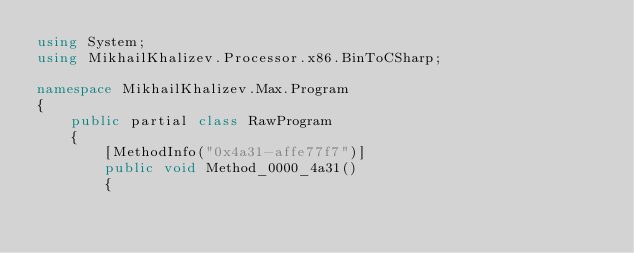<code> <loc_0><loc_0><loc_500><loc_500><_C#_>using System;
using MikhailKhalizev.Processor.x86.BinToCSharp;

namespace MikhailKhalizev.Max.Program
{
    public partial class RawProgram
    {
        [MethodInfo("0x4a31-affe77f7")]
        public void Method_0000_4a31()
        {</code> 